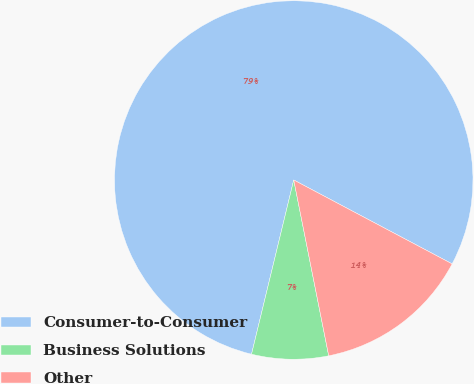Convert chart to OTSL. <chart><loc_0><loc_0><loc_500><loc_500><pie_chart><fcel>Consumer-to-Consumer<fcel>Business Solutions<fcel>Other<nl><fcel>78.97%<fcel>6.91%<fcel>14.12%<nl></chart> 